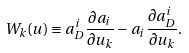Convert formula to latex. <formula><loc_0><loc_0><loc_500><loc_500>{ W } _ { k } ( u ) \equiv a _ { D } ^ { i } \frac { \partial a _ { i } } { \partial u _ { k } } - a _ { i } \frac { \partial a _ { D } ^ { i } } { \partial u _ { k } } .</formula> 